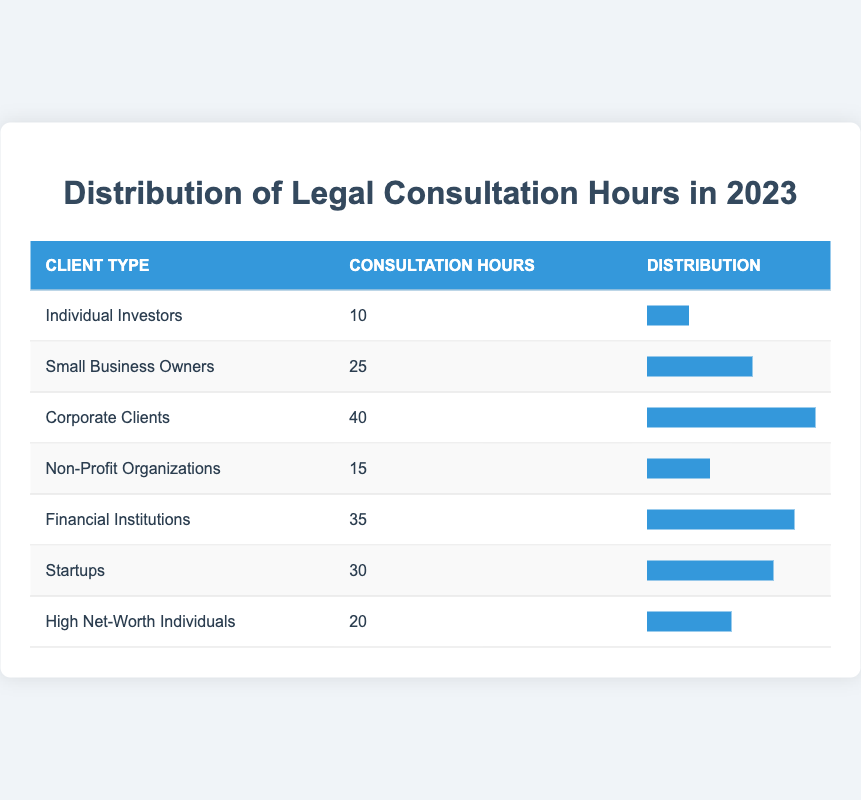What is the legal consultation hour total for all client types? To find the total legal consultation hours, I will add the hours for each client type: 10 (Individual Investors) + 25 (Small Business Owners) + 40 (Corporate Clients) + 15 (Non-Profit Organizations) + 35 (Financial Institutions) + 30 (Startups) + 20 (High Net-Worth Individuals) = 175 hours.
Answer: 175 Which client type received the most legal consultation hours? The table indicates that Corporate Clients have the highest legal consultation hours with 40 hours compared to other client types.
Answer: Corporate Clients Is the legal consultation hours for Non-Profit Organizations greater than that for Individual Investors? Non-Profit Organizations have 15 hours and Individual Investors have 10 hours. Since 15 is greater than 10, the statement is true.
Answer: Yes What is the average legal consultation hours across all client types? To calculate the average, first sum the total legal consultation hours (175) and divide by the number of client types (7): 175/7 = 25 hours average across client types.
Answer: 25 Do Small Business Owners have more consultation hours than High Net-Worth Individuals? Small Business Owners have 25 hours and High Net-Worth Individuals have 20 hours. Since 25 is greater than 20, the answer is true.
Answer: Yes What is the difference between the legal consultation hours of Corporate Clients and Financial Institutions? Corporate Clients have 40 hours and Financial Institutions have 35 hours. The difference is calculated as 40 - 35 = 5 hours.
Answer: 5 How many client types have legal consultation hours less than 30? The client types with less than 30 hours are Individual Investors (10), Non-Profit Organizations (15), and High Net-Worth Individuals (20). That's three client types in total with hours below 30.
Answer: 3 Which client type's legal consultation hours are closest to the average consultation hours? The average is 25 hours. Looking at the table, Small Business Owners (25) exactly match the average, while High Net-Worth Individuals at 20 is the next closest.
Answer: Small Business Owners 